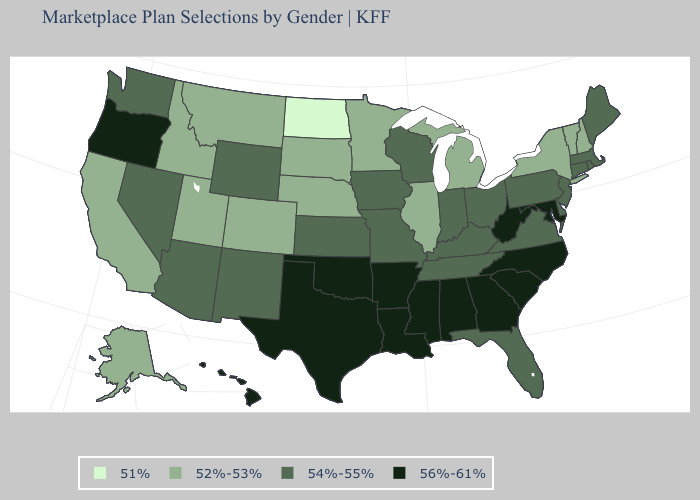Name the states that have a value in the range 52%-53%?
Concise answer only. Alaska, California, Colorado, Idaho, Illinois, Michigan, Minnesota, Montana, Nebraska, New Hampshire, New York, South Dakota, Utah, Vermont. Among the states that border Michigan , which have the lowest value?
Concise answer only. Indiana, Ohio, Wisconsin. What is the highest value in the USA?
Concise answer only. 56%-61%. Does the map have missing data?
Write a very short answer. No. What is the value of Utah?
Quick response, please. 52%-53%. Does Virginia have the lowest value in the USA?
Concise answer only. No. Name the states that have a value in the range 52%-53%?
Answer briefly. Alaska, California, Colorado, Idaho, Illinois, Michigan, Minnesota, Montana, Nebraska, New Hampshire, New York, South Dakota, Utah, Vermont. Name the states that have a value in the range 54%-55%?
Short answer required. Arizona, Connecticut, Delaware, Florida, Indiana, Iowa, Kansas, Kentucky, Maine, Massachusetts, Missouri, Nevada, New Jersey, New Mexico, Ohio, Pennsylvania, Rhode Island, Tennessee, Virginia, Washington, Wisconsin, Wyoming. Among the states that border Minnesota , which have the highest value?
Answer briefly. Iowa, Wisconsin. What is the value of New Hampshire?
Short answer required. 52%-53%. Does Vermont have the highest value in the Northeast?
Keep it brief. No. What is the lowest value in the USA?
Short answer required. 51%. Which states have the lowest value in the USA?
Give a very brief answer. North Dakota. What is the highest value in the West ?
Write a very short answer. 56%-61%. Name the states that have a value in the range 56%-61%?
Answer briefly. Alabama, Arkansas, Georgia, Hawaii, Louisiana, Maryland, Mississippi, North Carolina, Oklahoma, Oregon, South Carolina, Texas, West Virginia. 